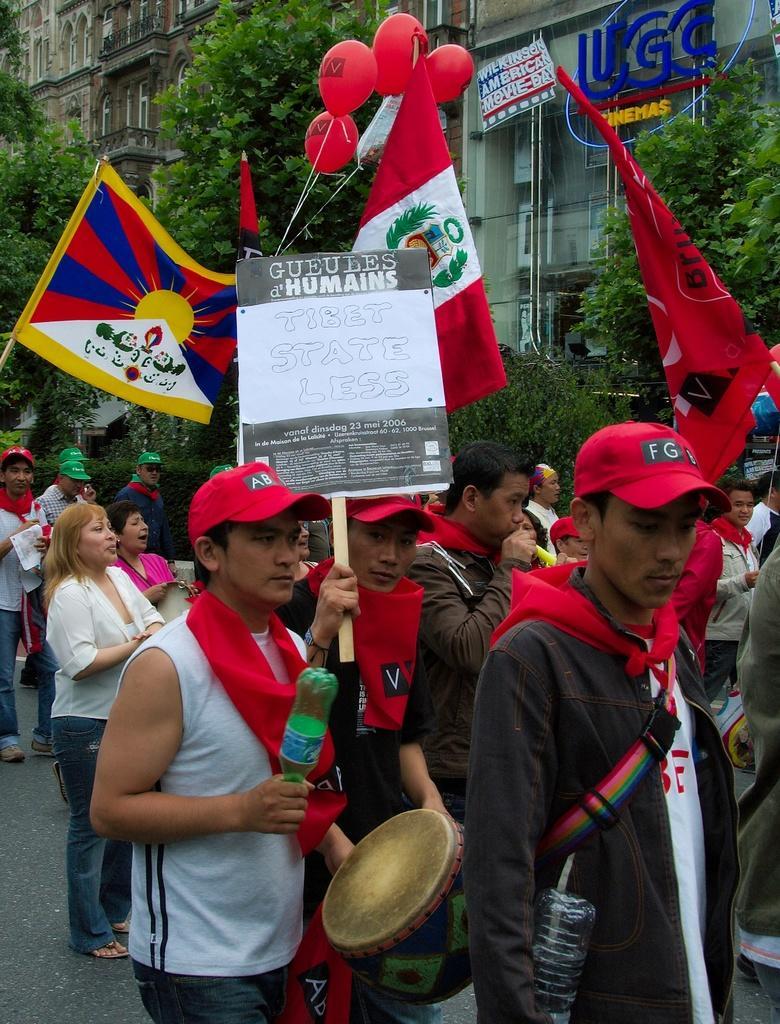How would you summarize this image in a sentence or two? In this image I see number of people in which this man is holding a bottle and a thing in his hands and this man is holding a board on which there is something written and few of them are holding flags which are colorful and I see the balloons over here. In the background I see the trees and the buildings and I see something is written over here too. 